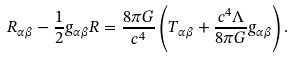<formula> <loc_0><loc_0><loc_500><loc_500>R _ { \alpha \beta } - \frac { 1 } { 2 } g _ { \alpha \beta } R = \frac { 8 \pi G } { c ^ { 4 } } \left ( T _ { \alpha \beta } + \frac { c ^ { 4 } \Lambda } { 8 \pi G } g _ { \alpha \beta } \right ) .</formula> 